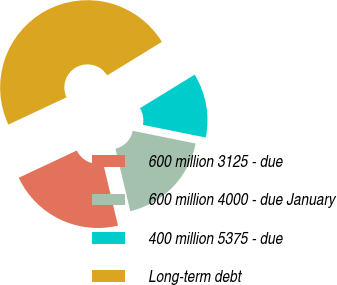<chart> <loc_0><loc_0><loc_500><loc_500><pie_chart><fcel>600 million 3125 - due<fcel>600 million 4000 - due January<fcel>400 million 5375 - due<fcel>Long-term debt<nl><fcel>21.74%<fcel>18.11%<fcel>11.92%<fcel>48.24%<nl></chart> 